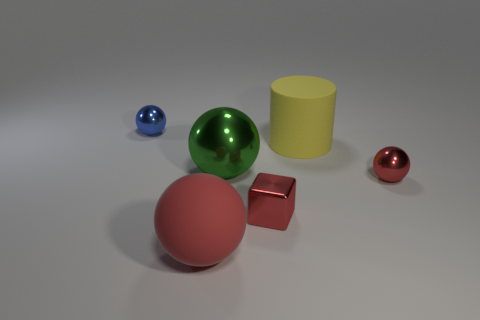The rubber object that is the same color as the small cube is what shape?
Provide a succinct answer. Sphere. Are there any small rubber things that have the same color as the big matte sphere?
Provide a short and direct response. No. Are there the same number of small objects that are on the right side of the tiny red shiny cube and large red objects that are to the right of the big green metal object?
Provide a succinct answer. No. Does the big red object have the same shape as the tiny red metal object to the right of the yellow cylinder?
Offer a very short reply. Yes. How many other things are the same material as the yellow thing?
Offer a terse response. 1. There is a blue metallic object; are there any tiny red metallic balls in front of it?
Make the answer very short. Yes. Is the size of the blue sphere the same as the ball in front of the red cube?
Offer a terse response. No. What color is the shiny object to the left of the matte thing that is in front of the small metallic cube?
Give a very brief answer. Blue. Is the size of the green thing the same as the metal cube?
Make the answer very short. No. The object that is left of the green thing and behind the matte sphere is what color?
Provide a short and direct response. Blue. 